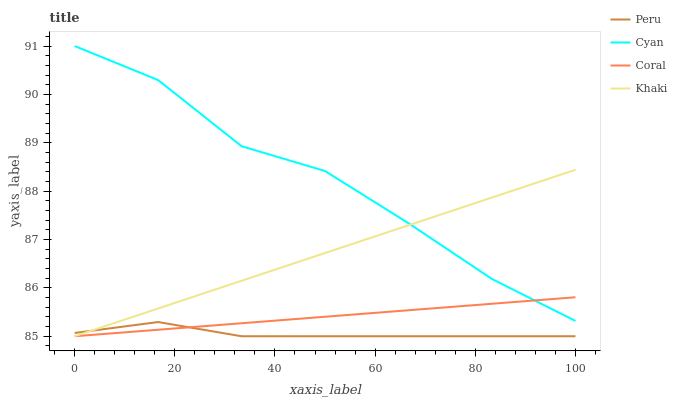Does Peru have the minimum area under the curve?
Answer yes or no. Yes. Does Cyan have the maximum area under the curve?
Answer yes or no. Yes. Does Coral have the minimum area under the curve?
Answer yes or no. No. Does Coral have the maximum area under the curve?
Answer yes or no. No. Is Coral the smoothest?
Answer yes or no. Yes. Is Cyan the roughest?
Answer yes or no. Yes. Is Khaki the smoothest?
Answer yes or no. No. Is Khaki the roughest?
Answer yes or no. No. Does Coral have the lowest value?
Answer yes or no. Yes. Does Cyan have the highest value?
Answer yes or no. Yes. Does Coral have the highest value?
Answer yes or no. No. Is Peru less than Cyan?
Answer yes or no. Yes. Is Cyan greater than Peru?
Answer yes or no. Yes. Does Khaki intersect Coral?
Answer yes or no. Yes. Is Khaki less than Coral?
Answer yes or no. No. Is Khaki greater than Coral?
Answer yes or no. No. Does Peru intersect Cyan?
Answer yes or no. No. 